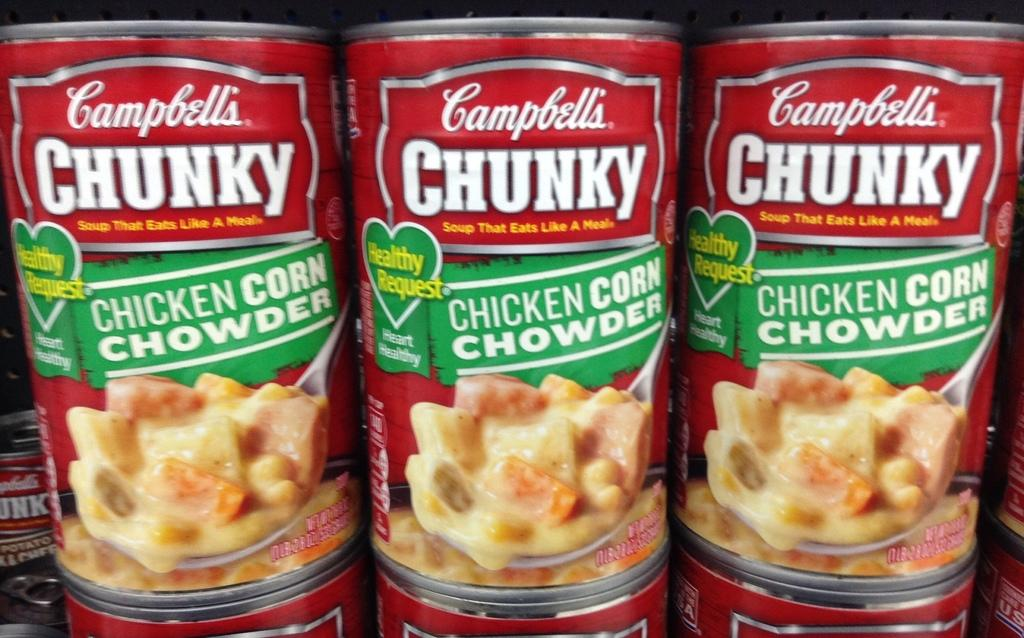What type of product is labeled on the cans in the image? The cans have "Chicken Corn Chowder" written on them. Can you describe the contents of the cans? The cans contain Chicken Corn Chowder, as indicated by the label. How does the volcano affect the payment process for the cans in the image? There is no volcano present in the image, and therefore it cannot affect the payment process for the cans. 